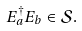Convert formula to latex. <formula><loc_0><loc_0><loc_500><loc_500>E _ { a } ^ { \dag } E _ { b } \in \mathcal { S } .</formula> 